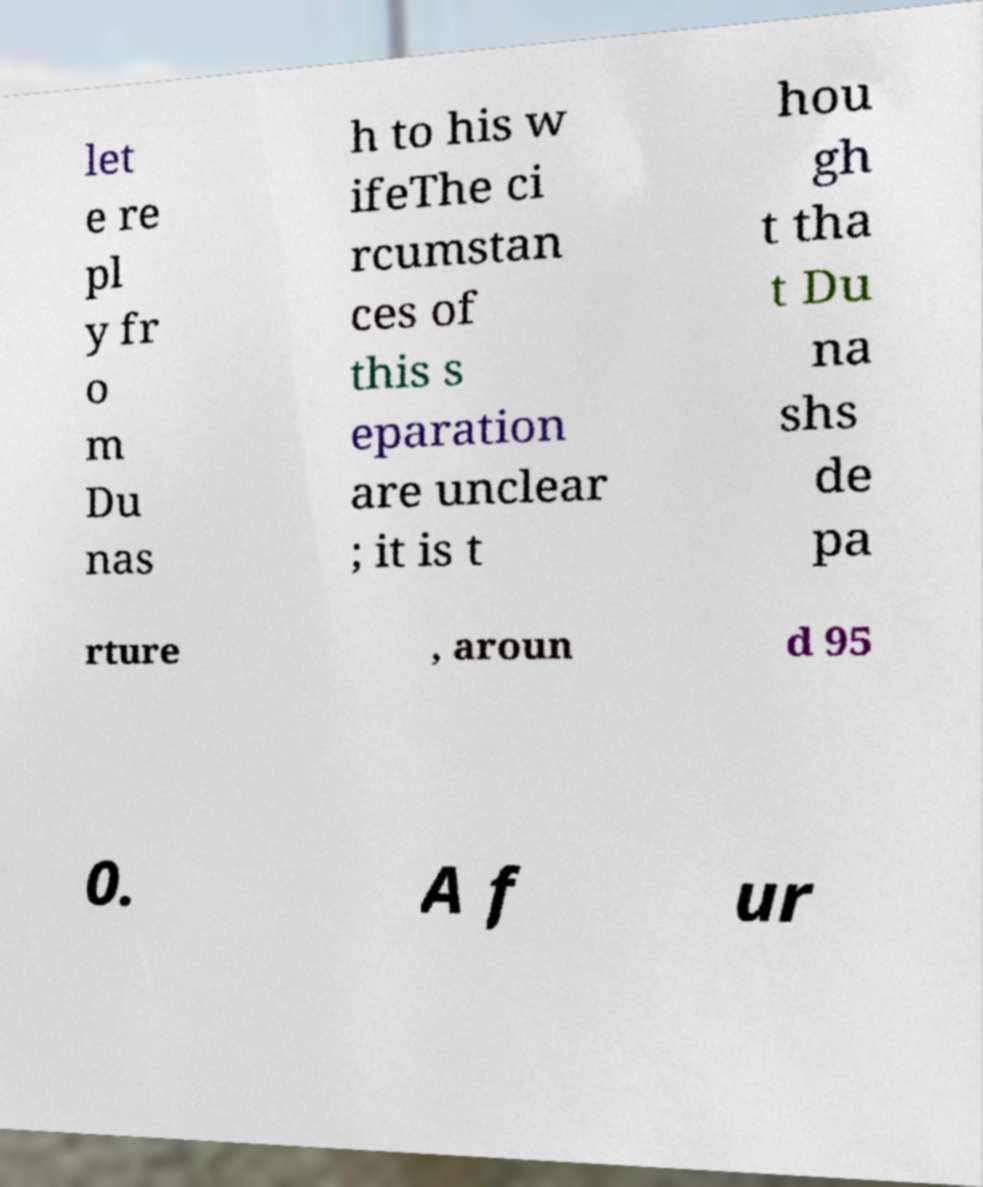There's text embedded in this image that I need extracted. Can you transcribe it verbatim? let e re pl y fr o m Du nas h to his w ifeThe ci rcumstan ces of this s eparation are unclear ; it is t hou gh t tha t Du na shs de pa rture , aroun d 95 0. A f ur 